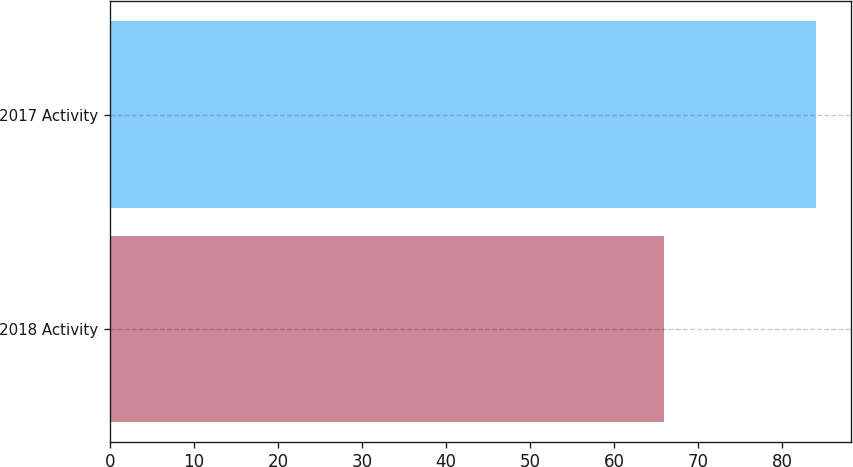Convert chart. <chart><loc_0><loc_0><loc_500><loc_500><bar_chart><fcel>2018 Activity<fcel>2017 Activity<nl><fcel>66<fcel>84<nl></chart> 